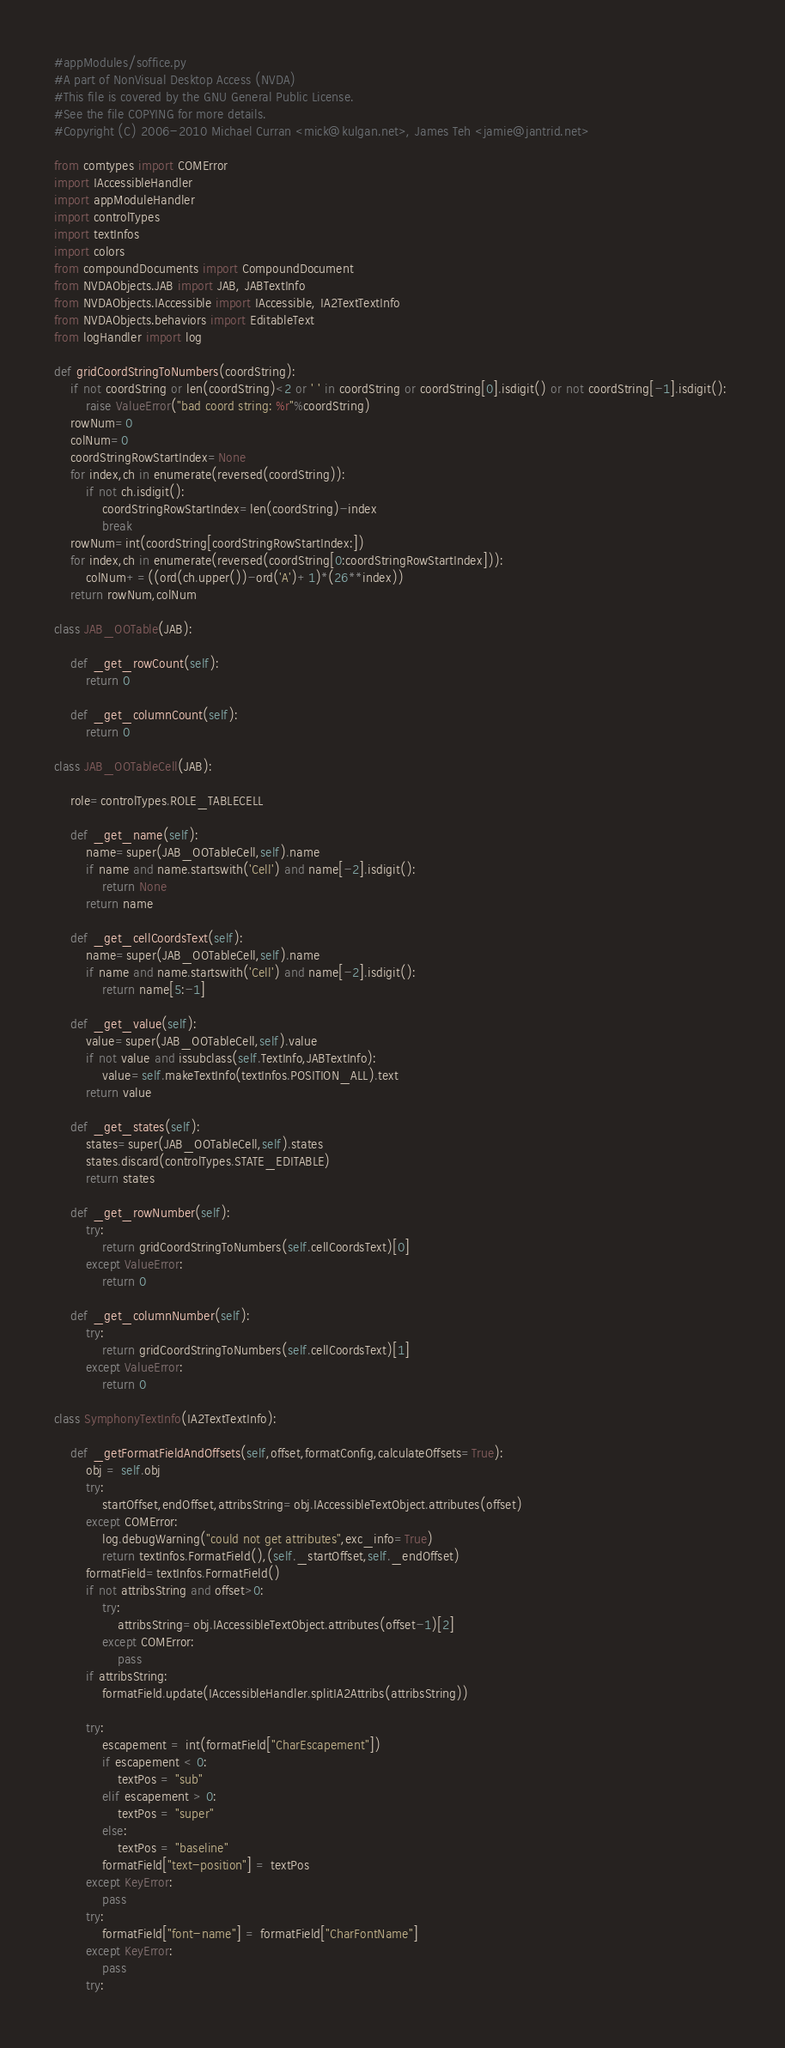Convert code to text. <code><loc_0><loc_0><loc_500><loc_500><_Python_>#appModules/soffice.py
#A part of NonVisual Desktop Access (NVDA)
#This file is covered by the GNU General Public License.
#See the file COPYING for more details.
#Copyright (C) 2006-2010 Michael Curran <mick@kulgan.net>, James Teh <jamie@jantrid.net>

from comtypes import COMError
import IAccessibleHandler
import appModuleHandler
import controlTypes
import textInfos
import colors
from compoundDocuments import CompoundDocument
from NVDAObjects.JAB import JAB, JABTextInfo
from NVDAObjects.IAccessible import IAccessible, IA2TextTextInfo
from NVDAObjects.behaviors import EditableText
from logHandler import log

def gridCoordStringToNumbers(coordString):
	if not coordString or len(coordString)<2 or ' ' in coordString or coordString[0].isdigit() or not coordString[-1].isdigit(): 
		raise ValueError("bad coord string: %r"%coordString) 
	rowNum=0
	colNum=0
	coordStringRowStartIndex=None
	for index,ch in enumerate(reversed(coordString)):
		if not ch.isdigit():
			coordStringRowStartIndex=len(coordString)-index
			break
	rowNum=int(coordString[coordStringRowStartIndex:])
	for index,ch in enumerate(reversed(coordString[0:coordStringRowStartIndex])):
		colNum+=((ord(ch.upper())-ord('A')+1)*(26**index))
	return rowNum,colNum

class JAB_OOTable(JAB):

	def _get_rowCount(self):
		return 0

	def _get_columnCount(self):
		return 0

class JAB_OOTableCell(JAB):

	role=controlTypes.ROLE_TABLECELL

	def _get_name(self):
		name=super(JAB_OOTableCell,self).name
		if name and name.startswith('Cell') and name[-2].isdigit():
			return None
		return name

	def _get_cellCoordsText(self):
		name=super(JAB_OOTableCell,self).name
		if name and name.startswith('Cell') and name[-2].isdigit():
			return name[5:-1]

	def _get_value(self):
		value=super(JAB_OOTableCell,self).value
		if not value and issubclass(self.TextInfo,JABTextInfo):
			value=self.makeTextInfo(textInfos.POSITION_ALL).text
		return value

	def _get_states(self):
		states=super(JAB_OOTableCell,self).states
		states.discard(controlTypes.STATE_EDITABLE)
		return states

	def _get_rowNumber(self):
		try:
			return gridCoordStringToNumbers(self.cellCoordsText)[0]
		except ValueError:
			return 0

	def _get_columnNumber(self):
		try:
			return gridCoordStringToNumbers(self.cellCoordsText)[1]
		except ValueError:
			return 0

class SymphonyTextInfo(IA2TextTextInfo):

	def _getFormatFieldAndOffsets(self,offset,formatConfig,calculateOffsets=True):
		obj = self.obj
		try:
			startOffset,endOffset,attribsString=obj.IAccessibleTextObject.attributes(offset)
		except COMError:
			log.debugWarning("could not get attributes",exc_info=True)
			return textInfos.FormatField(),(self._startOffset,self._endOffset)
		formatField=textInfos.FormatField()
		if not attribsString and offset>0:
			try:
				attribsString=obj.IAccessibleTextObject.attributes(offset-1)[2]
			except COMError:
				pass
		if attribsString:
			formatField.update(IAccessibleHandler.splitIA2Attribs(attribsString))

		try:
			escapement = int(formatField["CharEscapement"])
			if escapement < 0:
				textPos = "sub"
			elif escapement > 0:
				textPos = "super"
			else:
				textPos = "baseline"
			formatField["text-position"] = textPos
		except KeyError:
			pass
		try:
			formatField["font-name"] = formatField["CharFontName"]
		except KeyError:
			pass
		try:</code> 